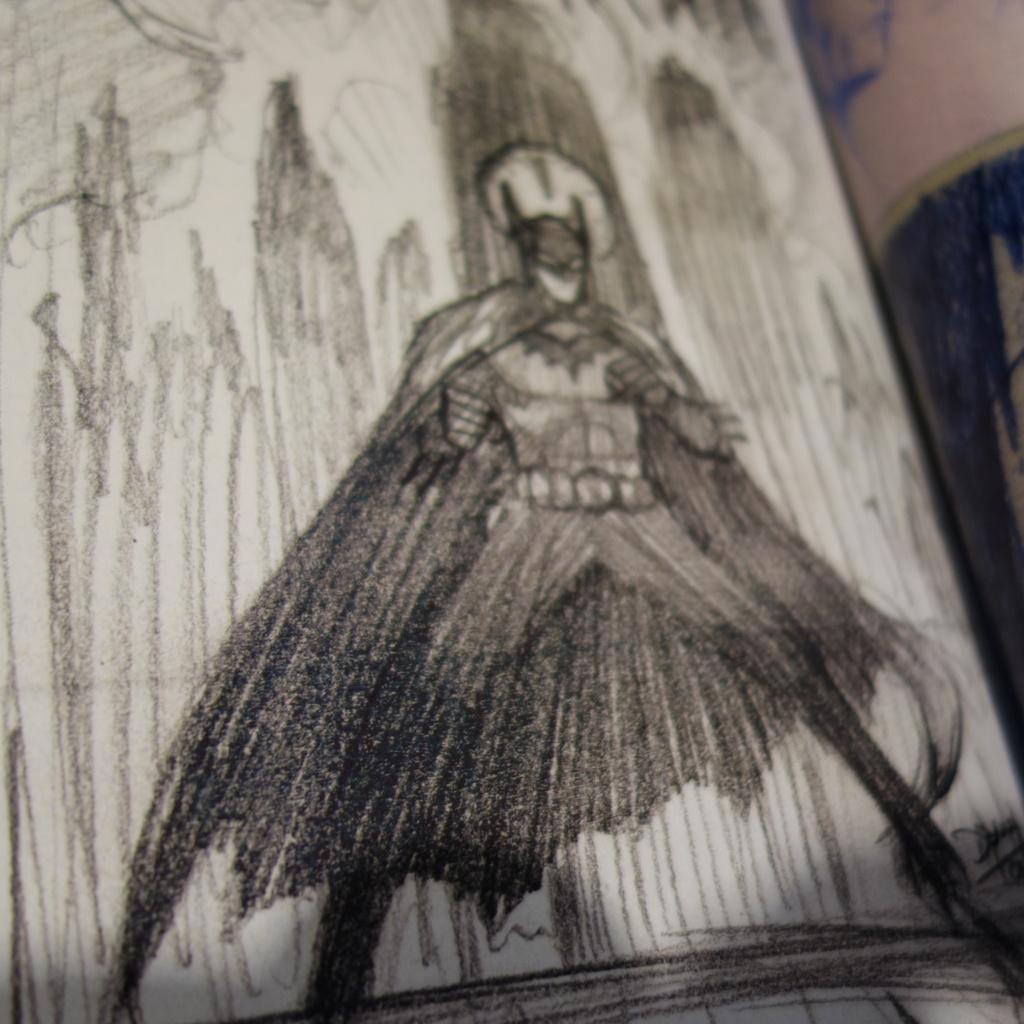What is depicted on the white object in the image? There is a drawing of a person on a white object in the image. What type of artwork can be seen on the wall in the image? There is a painting on the wall towards the right side of the image. What type of honey is being served at the party in the image? There is no party or honey present in the image; it only features a drawing on a white object and a painting on the wall. Can you describe the toad that is sitting on the person's shoulder in the image? There is no toad present in the image; the drawing only depicts a person. 